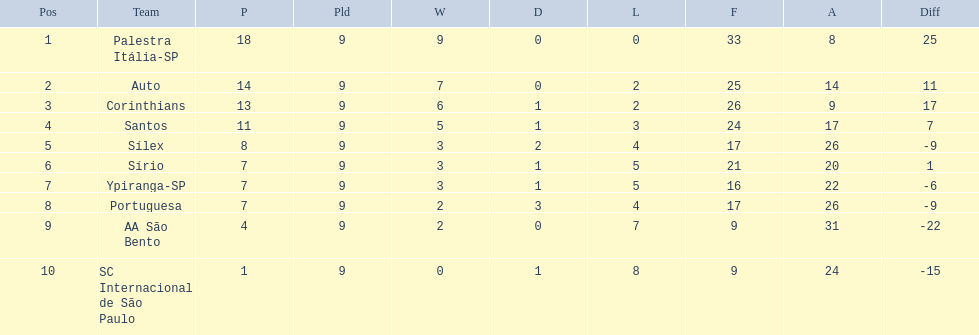What are all the teams? Palestra Itália-SP, Auto, Corinthians, Santos, Sílex, Sírio, Ypiranga-SP, Portuguesa, AA São Bento, SC Internacional de São Paulo. How many times did each team lose? 0, 2, 2, 3, 4, 5, 5, 4, 7, 8. And which team never lost? Palestra Itália-SP. 